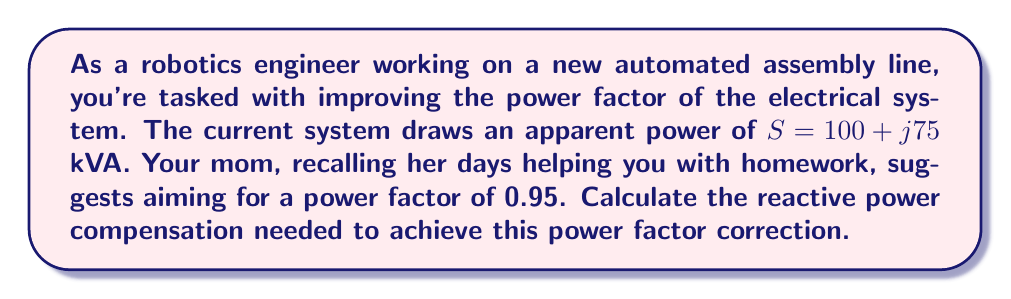Show me your answer to this math problem. Let's approach this step-by-step:

1) First, recall that the complex power $S$ is composed of real power $P$ and reactive power $Q$:

   $S = P + jQ$

2) In this case, $S = 100 + j75$ kVA. So, $P = 100$ kW and $Q = 75$ kVAR.

3) The current power factor can be calculated as:

   $PF_1 = \cos(\theta_1) = \frac{P}{|S|} = \frac{100}{\sqrt{100^2 + 75^2}} = 0.8$

4) We want to improve this to a power factor of 0.95. The new reactive power $Q_2$ can be calculated using:

   $\tan(\theta_2) = \frac{Q_2}{P}$, where $\cos(\theta_2) = 0.95$

5) We can find $\theta_2$ using:

   $\theta_2 = \arccos(0.95) = 0.3178$ radians

6) Now we can calculate $Q_2$:

   $Q_2 = P \tan(\theta_2) = 100 \tan(0.3178) = 32.87$ kVAR

7) The reactive power compensation needed is the difference between the initial and final reactive power:

   $Q_{comp} = Q_1 - Q_2 = 75 - 32.87 = 42.13$ kVAR

This means we need to add a capacitive reactive power of 42.13 kVAR to achieve the desired power factor correction.
Answer: The reactive power compensation needed is $42.13$ kVAR (capacitive). 